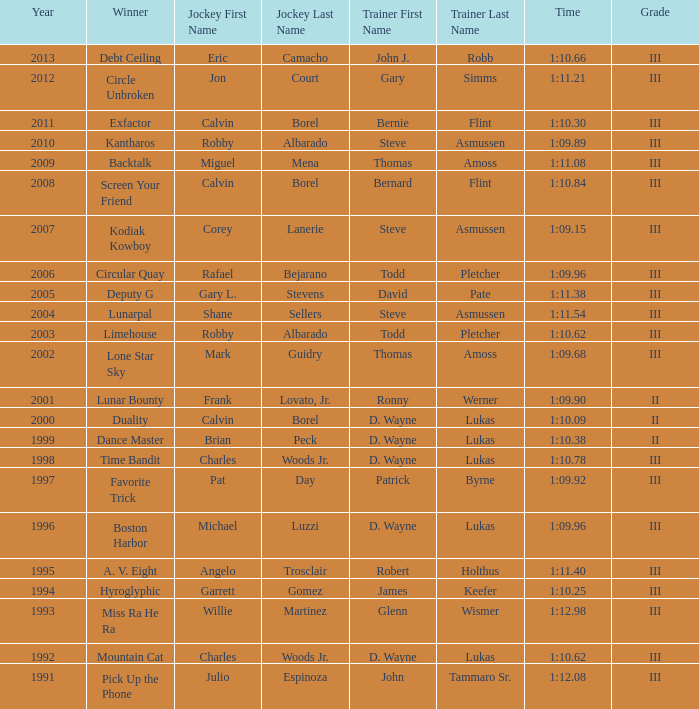Can you parse all the data within this table? {'header': ['Year', 'Winner', 'Jockey First Name', 'Jockey Last Name', 'Trainer First Name', 'Trainer Last Name', 'Time', 'Grade'], 'rows': [['2013', 'Debt Ceiling', 'Eric', 'Camacho', 'John J.', 'Robb', '1:10.66', 'III'], ['2012', 'Circle Unbroken', 'Jon', 'Court', 'Gary', 'Simms', '1:11.21', 'III'], ['2011', 'Exfactor', 'Calvin', 'Borel', 'Bernie', 'Flint', '1:10.30', 'III'], ['2010', 'Kantharos', 'Robby', 'Albarado', 'Steve', 'Asmussen', '1:09.89', 'III'], ['2009', 'Backtalk', 'Miguel', 'Mena', 'Thomas', 'Amoss', '1:11.08', 'III'], ['2008', 'Screen Your Friend', 'Calvin', 'Borel', 'Bernard', 'Flint', '1:10.84', 'III'], ['2007', 'Kodiak Kowboy', 'Corey', 'Lanerie', 'Steve', 'Asmussen', '1:09.15', 'III'], ['2006', 'Circular Quay', 'Rafael', 'Bejarano', 'Todd', 'Pletcher', '1:09.96', 'III'], ['2005', 'Deputy G', 'Gary L.', 'Stevens', 'David', 'Pate', '1:11.38', 'III'], ['2004', 'Lunarpal', 'Shane', 'Sellers', 'Steve', 'Asmussen', '1:11.54', 'III'], ['2003', 'Limehouse', 'Robby', 'Albarado', 'Todd', 'Pletcher', '1:10.62', 'III'], ['2002', 'Lone Star Sky', 'Mark', 'Guidry', 'Thomas', 'Amoss', '1:09.68', 'III'], ['2001', 'Lunar Bounty', 'Frank', 'Lovato, Jr.', 'Ronny', 'Werner', '1:09.90', 'II'], ['2000', 'Duality', 'Calvin', 'Borel', 'D. Wayne', 'Lukas', '1:10.09', 'II'], ['1999', 'Dance Master', 'Brian', 'Peck', 'D. Wayne', 'Lukas', '1:10.38', 'II'], ['1998', 'Time Bandit', 'Charles', 'Woods Jr.', 'D. Wayne', 'Lukas', '1:10.78', 'III'], ['1997', 'Favorite Trick', 'Pat', 'Day', 'Patrick', 'Byrne', '1:09.92', 'III'], ['1996', 'Boston Harbor', 'Michael', 'Luzzi', 'D. Wayne', 'Lukas', '1:09.96', 'III'], ['1995', 'A. V. Eight', 'Angelo', 'Trosclair', 'Robert', 'Holthus', '1:11.40', 'III'], ['1994', 'Hyroglyphic', 'Garrett', 'Gomez', 'James', 'Keefer', '1:10.25', 'III'], ['1993', 'Miss Ra He Ra', 'Willie', 'Martinez', 'Glenn', 'Wismer', '1:12.98', 'III'], ['1992', 'Mountain Cat', 'Charles', 'Woods Jr.', 'D. Wayne', 'Lukas', '1:10.62', 'III'], ['1991', 'Pick Up the Phone', 'Julio', 'Espinoza', 'John', 'Tammaro Sr.', '1:12.08', 'III']]} Which trainer had a time of 1:10.09 with a year less than 2009? D. Wayne Lukas. 